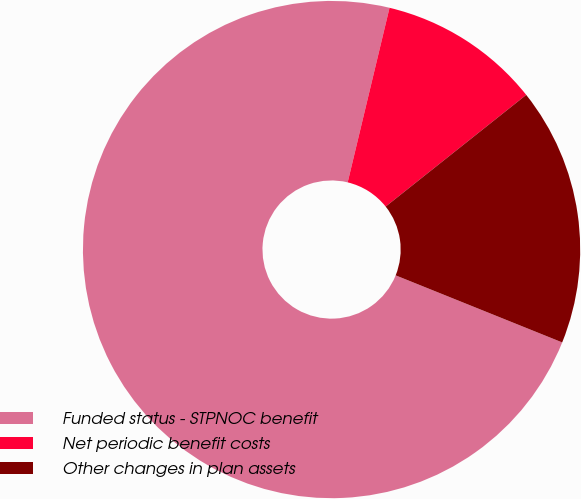Convert chart. <chart><loc_0><loc_0><loc_500><loc_500><pie_chart><fcel>Funded status - STPNOC benefit<fcel>Net periodic benefit costs<fcel>Other changes in plan assets<nl><fcel>72.66%<fcel>10.57%<fcel>16.78%<nl></chart> 